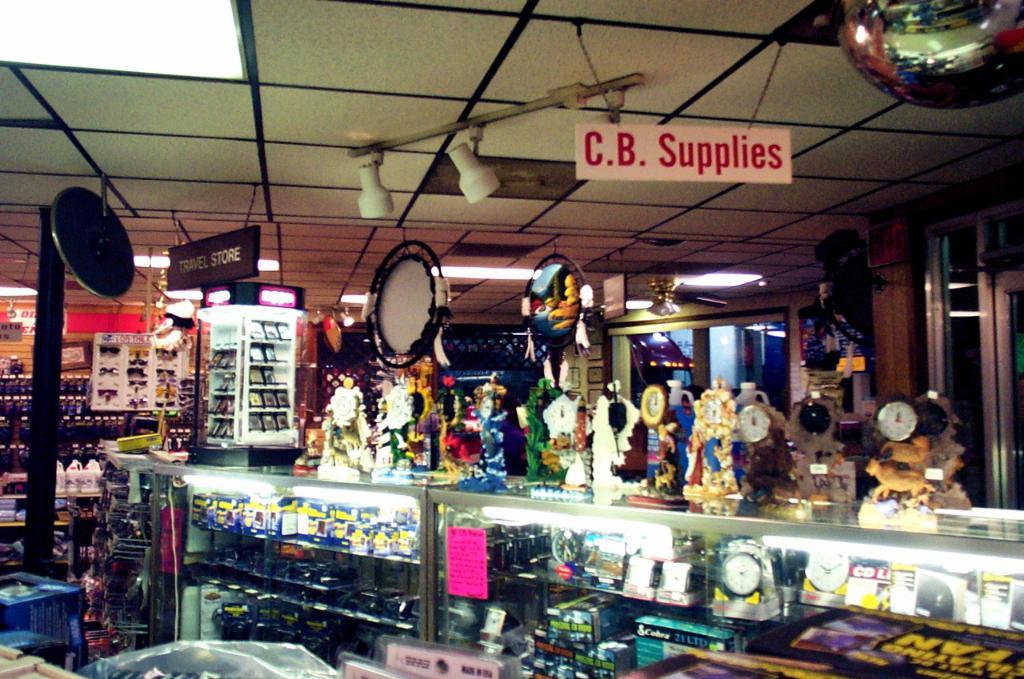What are all the objects on top of the counter?
Your answer should be very brief. Answering does not require reading text in the image. 